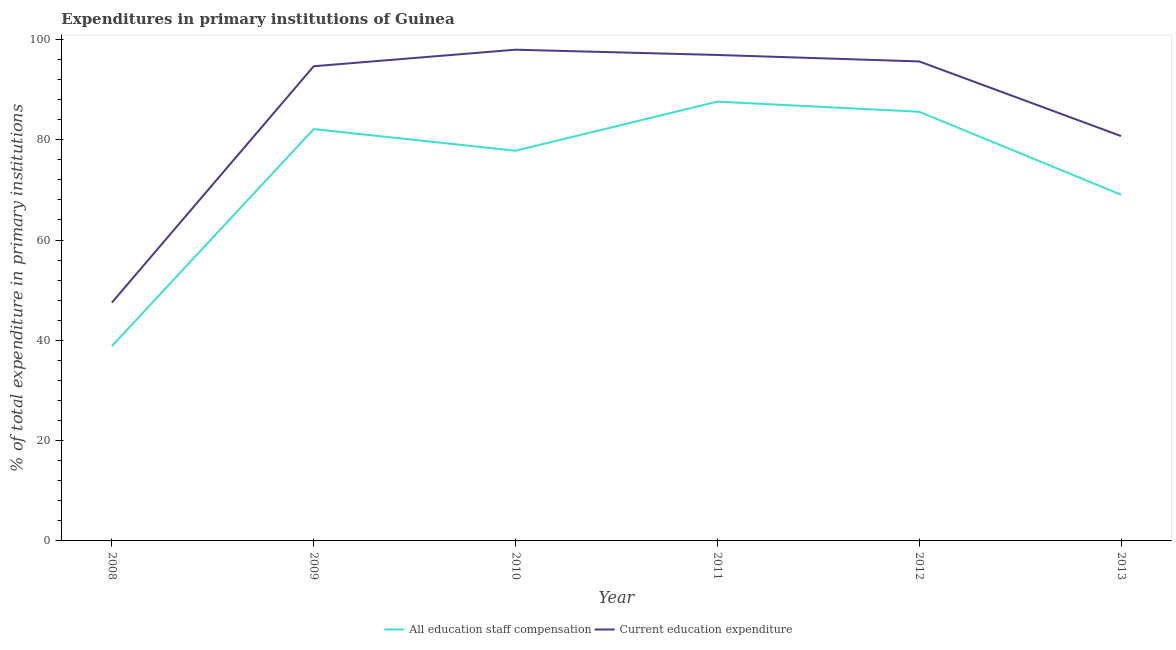How many different coloured lines are there?
Your answer should be very brief. 2. Is the number of lines equal to the number of legend labels?
Your response must be concise. Yes. What is the expenditure in staff compensation in 2010?
Give a very brief answer. 77.8. Across all years, what is the maximum expenditure in education?
Your response must be concise. 97.95. Across all years, what is the minimum expenditure in education?
Your response must be concise. 47.51. What is the total expenditure in education in the graph?
Offer a terse response. 513.37. What is the difference between the expenditure in education in 2010 and that in 2013?
Your answer should be very brief. 17.22. What is the difference between the expenditure in staff compensation in 2010 and the expenditure in education in 2009?
Your response must be concise. -16.85. What is the average expenditure in staff compensation per year?
Offer a very short reply. 73.49. In the year 2011, what is the difference between the expenditure in education and expenditure in staff compensation?
Provide a succinct answer. 9.31. In how many years, is the expenditure in staff compensation greater than 16 %?
Your answer should be compact. 6. What is the ratio of the expenditure in staff compensation in 2008 to that in 2012?
Your answer should be very brief. 0.45. Is the expenditure in education in 2010 less than that in 2013?
Give a very brief answer. No. What is the difference between the highest and the second highest expenditure in staff compensation?
Provide a succinct answer. 2.01. What is the difference between the highest and the lowest expenditure in education?
Your answer should be very brief. 50.44. In how many years, is the expenditure in education greater than the average expenditure in education taken over all years?
Provide a short and direct response. 4. Is the sum of the expenditure in education in 2009 and 2010 greater than the maximum expenditure in staff compensation across all years?
Keep it short and to the point. Yes. How many years are there in the graph?
Your answer should be very brief. 6. What is the difference between two consecutive major ticks on the Y-axis?
Your response must be concise. 20. Are the values on the major ticks of Y-axis written in scientific E-notation?
Ensure brevity in your answer.  No. Does the graph contain any zero values?
Give a very brief answer. No. Where does the legend appear in the graph?
Your answer should be very brief. Bottom center. How many legend labels are there?
Offer a terse response. 2. How are the legend labels stacked?
Make the answer very short. Horizontal. What is the title of the graph?
Your response must be concise. Expenditures in primary institutions of Guinea. What is the label or title of the Y-axis?
Ensure brevity in your answer.  % of total expenditure in primary institutions. What is the % of total expenditure in primary institutions in All education staff compensation in 2008?
Offer a very short reply. 38.84. What is the % of total expenditure in primary institutions in Current education expenditure in 2008?
Your answer should be compact. 47.51. What is the % of total expenditure in primary institutions in All education staff compensation in 2009?
Keep it short and to the point. 82.12. What is the % of total expenditure in primary institutions in Current education expenditure in 2009?
Your answer should be compact. 94.65. What is the % of total expenditure in primary institutions in All education staff compensation in 2010?
Your answer should be very brief. 77.8. What is the % of total expenditure in primary institutions of Current education expenditure in 2010?
Ensure brevity in your answer.  97.95. What is the % of total expenditure in primary institutions of All education staff compensation in 2011?
Ensure brevity in your answer.  87.59. What is the % of total expenditure in primary institutions in Current education expenditure in 2011?
Provide a short and direct response. 96.9. What is the % of total expenditure in primary institutions in All education staff compensation in 2012?
Ensure brevity in your answer.  85.58. What is the % of total expenditure in primary institutions of Current education expenditure in 2012?
Keep it short and to the point. 95.61. What is the % of total expenditure in primary institutions of All education staff compensation in 2013?
Your answer should be very brief. 69.03. What is the % of total expenditure in primary institutions of Current education expenditure in 2013?
Offer a very short reply. 80.73. Across all years, what is the maximum % of total expenditure in primary institutions in All education staff compensation?
Offer a terse response. 87.59. Across all years, what is the maximum % of total expenditure in primary institutions in Current education expenditure?
Keep it short and to the point. 97.95. Across all years, what is the minimum % of total expenditure in primary institutions in All education staff compensation?
Offer a very short reply. 38.84. Across all years, what is the minimum % of total expenditure in primary institutions in Current education expenditure?
Provide a succinct answer. 47.51. What is the total % of total expenditure in primary institutions of All education staff compensation in the graph?
Keep it short and to the point. 440.97. What is the total % of total expenditure in primary institutions of Current education expenditure in the graph?
Ensure brevity in your answer.  513.37. What is the difference between the % of total expenditure in primary institutions in All education staff compensation in 2008 and that in 2009?
Provide a short and direct response. -43.28. What is the difference between the % of total expenditure in primary institutions of Current education expenditure in 2008 and that in 2009?
Your answer should be very brief. -47.14. What is the difference between the % of total expenditure in primary institutions of All education staff compensation in 2008 and that in 2010?
Offer a terse response. -38.97. What is the difference between the % of total expenditure in primary institutions of Current education expenditure in 2008 and that in 2010?
Keep it short and to the point. -50.44. What is the difference between the % of total expenditure in primary institutions of All education staff compensation in 2008 and that in 2011?
Your answer should be very brief. -48.75. What is the difference between the % of total expenditure in primary institutions in Current education expenditure in 2008 and that in 2011?
Your response must be concise. -49.39. What is the difference between the % of total expenditure in primary institutions in All education staff compensation in 2008 and that in 2012?
Provide a short and direct response. -46.74. What is the difference between the % of total expenditure in primary institutions in Current education expenditure in 2008 and that in 2012?
Your answer should be compact. -48.1. What is the difference between the % of total expenditure in primary institutions in All education staff compensation in 2008 and that in 2013?
Provide a short and direct response. -30.2. What is the difference between the % of total expenditure in primary institutions of Current education expenditure in 2008 and that in 2013?
Make the answer very short. -33.22. What is the difference between the % of total expenditure in primary institutions of All education staff compensation in 2009 and that in 2010?
Ensure brevity in your answer.  4.31. What is the difference between the % of total expenditure in primary institutions in Current education expenditure in 2009 and that in 2010?
Your answer should be very brief. -3.3. What is the difference between the % of total expenditure in primary institutions of All education staff compensation in 2009 and that in 2011?
Offer a terse response. -5.47. What is the difference between the % of total expenditure in primary institutions of Current education expenditure in 2009 and that in 2011?
Offer a terse response. -2.25. What is the difference between the % of total expenditure in primary institutions of All education staff compensation in 2009 and that in 2012?
Your answer should be very brief. -3.46. What is the difference between the % of total expenditure in primary institutions in Current education expenditure in 2009 and that in 2012?
Provide a short and direct response. -0.96. What is the difference between the % of total expenditure in primary institutions in All education staff compensation in 2009 and that in 2013?
Offer a terse response. 13.08. What is the difference between the % of total expenditure in primary institutions in Current education expenditure in 2009 and that in 2013?
Provide a short and direct response. 13.92. What is the difference between the % of total expenditure in primary institutions of All education staff compensation in 2010 and that in 2011?
Provide a short and direct response. -9.79. What is the difference between the % of total expenditure in primary institutions of Current education expenditure in 2010 and that in 2011?
Provide a short and direct response. 1.05. What is the difference between the % of total expenditure in primary institutions in All education staff compensation in 2010 and that in 2012?
Keep it short and to the point. -7.77. What is the difference between the % of total expenditure in primary institutions in Current education expenditure in 2010 and that in 2012?
Give a very brief answer. 2.34. What is the difference between the % of total expenditure in primary institutions of All education staff compensation in 2010 and that in 2013?
Your answer should be compact. 8.77. What is the difference between the % of total expenditure in primary institutions of Current education expenditure in 2010 and that in 2013?
Your response must be concise. 17.22. What is the difference between the % of total expenditure in primary institutions in All education staff compensation in 2011 and that in 2012?
Keep it short and to the point. 2.01. What is the difference between the % of total expenditure in primary institutions in Current education expenditure in 2011 and that in 2012?
Provide a short and direct response. 1.29. What is the difference between the % of total expenditure in primary institutions in All education staff compensation in 2011 and that in 2013?
Make the answer very short. 18.56. What is the difference between the % of total expenditure in primary institutions in Current education expenditure in 2011 and that in 2013?
Provide a succinct answer. 16.17. What is the difference between the % of total expenditure in primary institutions in All education staff compensation in 2012 and that in 2013?
Make the answer very short. 16.54. What is the difference between the % of total expenditure in primary institutions in Current education expenditure in 2012 and that in 2013?
Make the answer very short. 14.88. What is the difference between the % of total expenditure in primary institutions in All education staff compensation in 2008 and the % of total expenditure in primary institutions in Current education expenditure in 2009?
Provide a succinct answer. -55.81. What is the difference between the % of total expenditure in primary institutions of All education staff compensation in 2008 and the % of total expenditure in primary institutions of Current education expenditure in 2010?
Provide a short and direct response. -59.11. What is the difference between the % of total expenditure in primary institutions in All education staff compensation in 2008 and the % of total expenditure in primary institutions in Current education expenditure in 2011?
Provide a succinct answer. -58.06. What is the difference between the % of total expenditure in primary institutions of All education staff compensation in 2008 and the % of total expenditure in primary institutions of Current education expenditure in 2012?
Ensure brevity in your answer.  -56.77. What is the difference between the % of total expenditure in primary institutions in All education staff compensation in 2008 and the % of total expenditure in primary institutions in Current education expenditure in 2013?
Provide a short and direct response. -41.89. What is the difference between the % of total expenditure in primary institutions in All education staff compensation in 2009 and the % of total expenditure in primary institutions in Current education expenditure in 2010?
Make the answer very short. -15.83. What is the difference between the % of total expenditure in primary institutions of All education staff compensation in 2009 and the % of total expenditure in primary institutions of Current education expenditure in 2011?
Your answer should be compact. -14.78. What is the difference between the % of total expenditure in primary institutions of All education staff compensation in 2009 and the % of total expenditure in primary institutions of Current education expenditure in 2012?
Make the answer very short. -13.49. What is the difference between the % of total expenditure in primary institutions in All education staff compensation in 2009 and the % of total expenditure in primary institutions in Current education expenditure in 2013?
Make the answer very short. 1.38. What is the difference between the % of total expenditure in primary institutions of All education staff compensation in 2010 and the % of total expenditure in primary institutions of Current education expenditure in 2011?
Your answer should be compact. -19.1. What is the difference between the % of total expenditure in primary institutions of All education staff compensation in 2010 and the % of total expenditure in primary institutions of Current education expenditure in 2012?
Make the answer very short. -17.81. What is the difference between the % of total expenditure in primary institutions in All education staff compensation in 2010 and the % of total expenditure in primary institutions in Current education expenditure in 2013?
Provide a short and direct response. -2.93. What is the difference between the % of total expenditure in primary institutions of All education staff compensation in 2011 and the % of total expenditure in primary institutions of Current education expenditure in 2012?
Keep it short and to the point. -8.02. What is the difference between the % of total expenditure in primary institutions in All education staff compensation in 2011 and the % of total expenditure in primary institutions in Current education expenditure in 2013?
Provide a short and direct response. 6.86. What is the difference between the % of total expenditure in primary institutions in All education staff compensation in 2012 and the % of total expenditure in primary institutions in Current education expenditure in 2013?
Make the answer very short. 4.84. What is the average % of total expenditure in primary institutions of All education staff compensation per year?
Give a very brief answer. 73.49. What is the average % of total expenditure in primary institutions in Current education expenditure per year?
Provide a short and direct response. 85.56. In the year 2008, what is the difference between the % of total expenditure in primary institutions of All education staff compensation and % of total expenditure in primary institutions of Current education expenditure?
Keep it short and to the point. -8.67. In the year 2009, what is the difference between the % of total expenditure in primary institutions in All education staff compensation and % of total expenditure in primary institutions in Current education expenditure?
Offer a very short reply. -12.53. In the year 2010, what is the difference between the % of total expenditure in primary institutions of All education staff compensation and % of total expenditure in primary institutions of Current education expenditure?
Your response must be concise. -20.15. In the year 2011, what is the difference between the % of total expenditure in primary institutions in All education staff compensation and % of total expenditure in primary institutions in Current education expenditure?
Your answer should be very brief. -9.31. In the year 2012, what is the difference between the % of total expenditure in primary institutions of All education staff compensation and % of total expenditure in primary institutions of Current education expenditure?
Give a very brief answer. -10.04. In the year 2013, what is the difference between the % of total expenditure in primary institutions of All education staff compensation and % of total expenditure in primary institutions of Current education expenditure?
Your answer should be compact. -11.7. What is the ratio of the % of total expenditure in primary institutions of All education staff compensation in 2008 to that in 2009?
Offer a terse response. 0.47. What is the ratio of the % of total expenditure in primary institutions in Current education expenditure in 2008 to that in 2009?
Keep it short and to the point. 0.5. What is the ratio of the % of total expenditure in primary institutions in All education staff compensation in 2008 to that in 2010?
Give a very brief answer. 0.5. What is the ratio of the % of total expenditure in primary institutions in Current education expenditure in 2008 to that in 2010?
Your response must be concise. 0.49. What is the ratio of the % of total expenditure in primary institutions in All education staff compensation in 2008 to that in 2011?
Make the answer very short. 0.44. What is the ratio of the % of total expenditure in primary institutions in Current education expenditure in 2008 to that in 2011?
Offer a very short reply. 0.49. What is the ratio of the % of total expenditure in primary institutions in All education staff compensation in 2008 to that in 2012?
Ensure brevity in your answer.  0.45. What is the ratio of the % of total expenditure in primary institutions of Current education expenditure in 2008 to that in 2012?
Offer a terse response. 0.5. What is the ratio of the % of total expenditure in primary institutions in All education staff compensation in 2008 to that in 2013?
Your answer should be compact. 0.56. What is the ratio of the % of total expenditure in primary institutions of Current education expenditure in 2008 to that in 2013?
Provide a short and direct response. 0.59. What is the ratio of the % of total expenditure in primary institutions of All education staff compensation in 2009 to that in 2010?
Offer a very short reply. 1.06. What is the ratio of the % of total expenditure in primary institutions in Current education expenditure in 2009 to that in 2010?
Give a very brief answer. 0.97. What is the ratio of the % of total expenditure in primary institutions in All education staff compensation in 2009 to that in 2011?
Your answer should be very brief. 0.94. What is the ratio of the % of total expenditure in primary institutions of Current education expenditure in 2009 to that in 2011?
Your answer should be compact. 0.98. What is the ratio of the % of total expenditure in primary institutions in All education staff compensation in 2009 to that in 2012?
Provide a short and direct response. 0.96. What is the ratio of the % of total expenditure in primary institutions of All education staff compensation in 2009 to that in 2013?
Your answer should be compact. 1.19. What is the ratio of the % of total expenditure in primary institutions in Current education expenditure in 2009 to that in 2013?
Provide a succinct answer. 1.17. What is the ratio of the % of total expenditure in primary institutions in All education staff compensation in 2010 to that in 2011?
Offer a terse response. 0.89. What is the ratio of the % of total expenditure in primary institutions in Current education expenditure in 2010 to that in 2011?
Provide a succinct answer. 1.01. What is the ratio of the % of total expenditure in primary institutions of All education staff compensation in 2010 to that in 2012?
Provide a succinct answer. 0.91. What is the ratio of the % of total expenditure in primary institutions in Current education expenditure in 2010 to that in 2012?
Your answer should be very brief. 1.02. What is the ratio of the % of total expenditure in primary institutions of All education staff compensation in 2010 to that in 2013?
Provide a short and direct response. 1.13. What is the ratio of the % of total expenditure in primary institutions of Current education expenditure in 2010 to that in 2013?
Offer a terse response. 1.21. What is the ratio of the % of total expenditure in primary institutions of All education staff compensation in 2011 to that in 2012?
Provide a short and direct response. 1.02. What is the ratio of the % of total expenditure in primary institutions of Current education expenditure in 2011 to that in 2012?
Offer a very short reply. 1.01. What is the ratio of the % of total expenditure in primary institutions of All education staff compensation in 2011 to that in 2013?
Your answer should be very brief. 1.27. What is the ratio of the % of total expenditure in primary institutions in Current education expenditure in 2011 to that in 2013?
Provide a succinct answer. 1.2. What is the ratio of the % of total expenditure in primary institutions in All education staff compensation in 2012 to that in 2013?
Ensure brevity in your answer.  1.24. What is the ratio of the % of total expenditure in primary institutions of Current education expenditure in 2012 to that in 2013?
Give a very brief answer. 1.18. What is the difference between the highest and the second highest % of total expenditure in primary institutions in All education staff compensation?
Provide a short and direct response. 2.01. What is the difference between the highest and the second highest % of total expenditure in primary institutions of Current education expenditure?
Your response must be concise. 1.05. What is the difference between the highest and the lowest % of total expenditure in primary institutions of All education staff compensation?
Ensure brevity in your answer.  48.75. What is the difference between the highest and the lowest % of total expenditure in primary institutions in Current education expenditure?
Offer a very short reply. 50.44. 